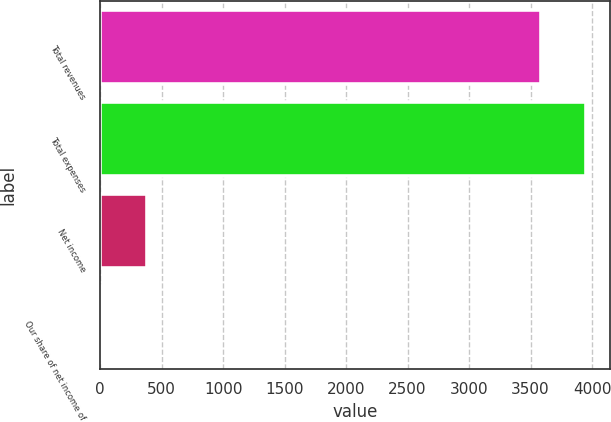<chart> <loc_0><loc_0><loc_500><loc_500><bar_chart><fcel>Total revenues<fcel>Total expenses<fcel>Net income<fcel>Our share of net income of<nl><fcel>3582.6<fcel>3947.28<fcel>378.88<fcel>14.2<nl></chart> 